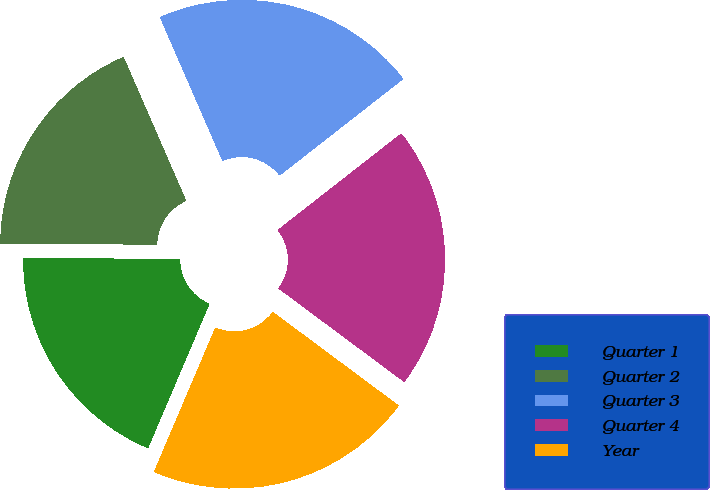Convert chart. <chart><loc_0><loc_0><loc_500><loc_500><pie_chart><fcel>Quarter 1<fcel>Quarter 2<fcel>Quarter 3<fcel>Quarter 4<fcel>Year<nl><fcel>18.72%<fcel>18.34%<fcel>20.98%<fcel>20.73%<fcel>21.23%<nl></chart> 